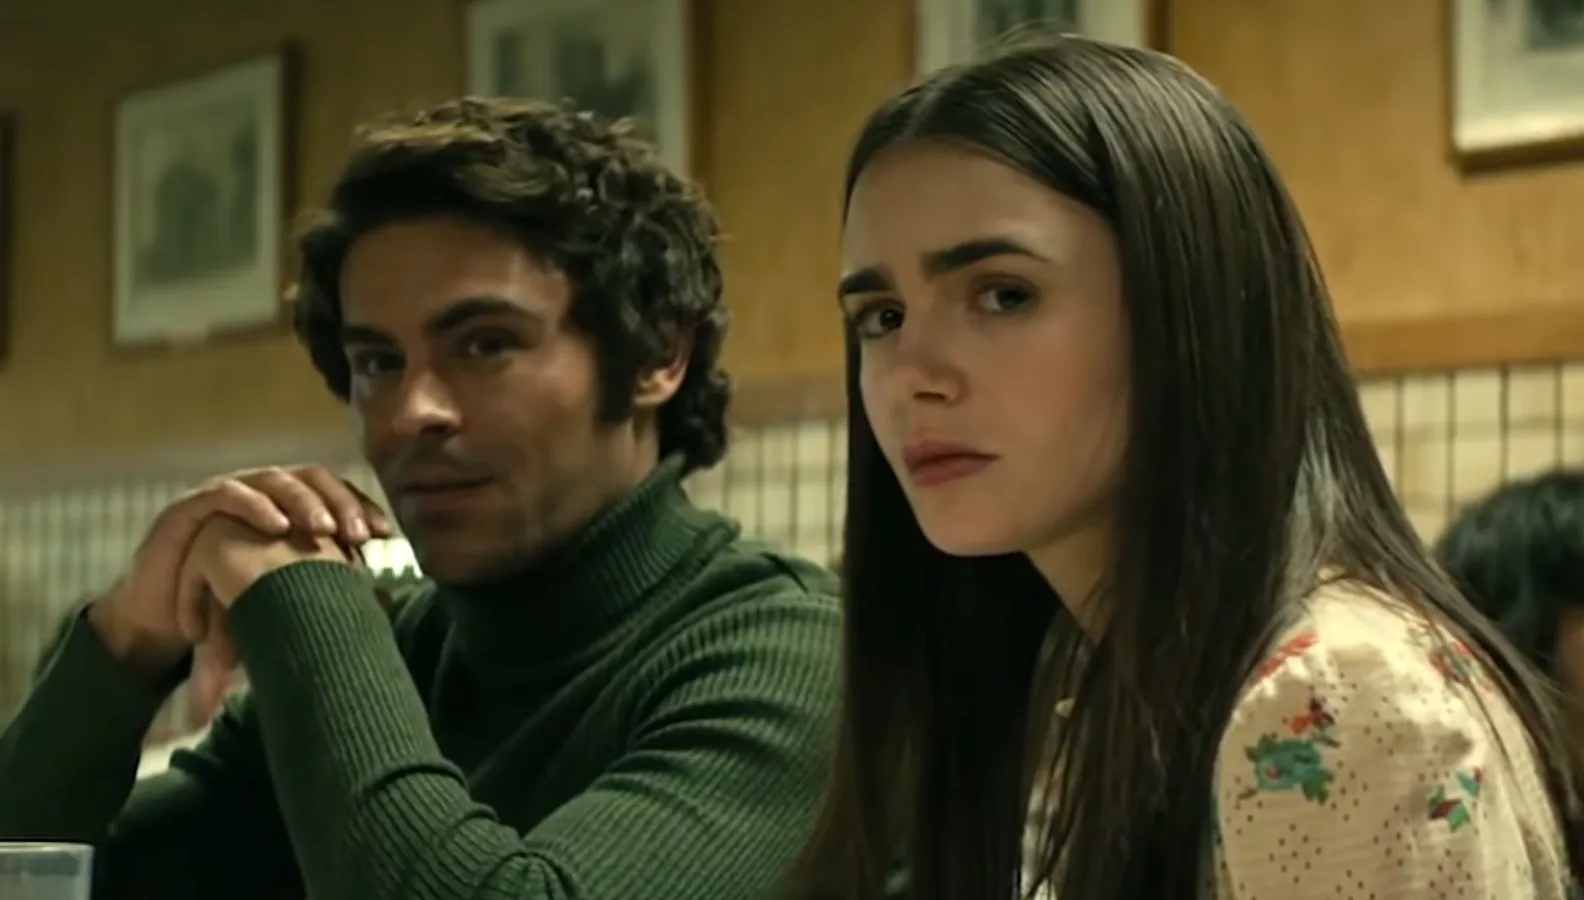Imagine a backstory for this scene. What led up to this intense moment? Prior to this scene, the characters could have been involved in a high-stakes situation. Perhaps they are partners in uncovering a mystery or dealing with a complex personal relationship. The diner serves as a neutral ground where they can openly discuss their concerns and plans. There's a strong sense that the conversation is critical, possibly involving revelations or decisions that will impact their future. The muted tension between them hints at unresolved emotions and secrets just beneath the surface. What are some potential outcomes following this moment? Following this moment, several outcomes could unfold:
1. **Resolution**: The characters might come to a clear understanding or agreement, steering their journey towards a definitive goal.
2. **Conflict**: The conversation could escalate into a conflict, bringing underlying tensions to the forefront, potentially causing a rift between them.
3. **Revelation**: One of the characters may reveal a critical piece of information that changes the course of their story, introducing new challenges or avenues to explore.
4. **Decision**: A significant decision could be made, propelling them into the next phase of their journey with renewed purpose or facing new obstacles. What if these characters were in a sci-fi universe? Describe this scene with that twist. In a sci-fi universe, this scene transforms dramatically. The diner could be a floating cafe in the middle of a space station overlooking a bustling galaxy. Zac Efron’s green turtleneck might be an advanced fabric that can adjust to different atmospheres, while Lily Collins’ floral blouse could be embedded with nanotechnology for communication or protection. Their serious expressions remain, but now the context might involve a conversation about intergalactic politics, smuggling rare alien artifacts, or a looming threat from a hostile race. The atmosphere is charged not just with personal stakes, but with the vast expanse of space and the unknown challenges it brings. Write a creative dialogue snippet where the characters reveal a hidden agenda. Zac: *'We don't have much time before they find out, Lily. The data chip is safe, but we need to act fast.'*
Lily: *'I can't believe we're involved in this. Do you really think exposing the truth will change anything?'*
Zac: *'It's our only chance. We've come too far to turn back now. They need to know what's really happening on Titan.'*
Lily: *'Alright, I'm with you. But we need to trust each other completely. No more secrets.'*
Zac: *'Agreed. From this point on, transparency is our best weapon.'* 